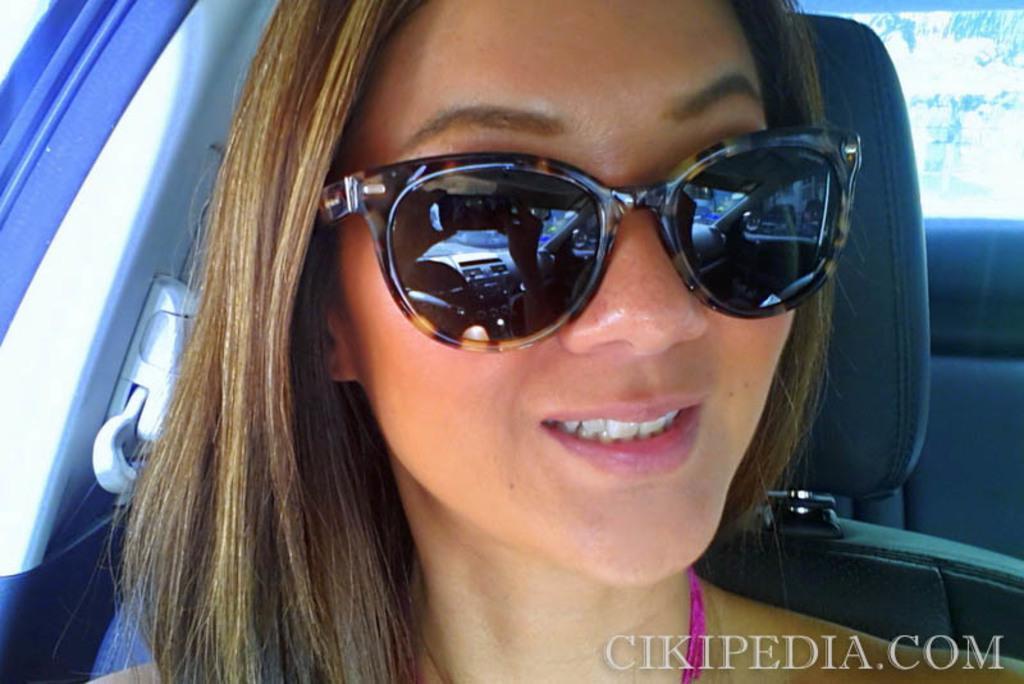How would you summarize this image in a sentence or two? In this image we can see a woman face and she wore goggles. Picture inside of a vehicle. In the right side bottom of the image there is a watermark. 